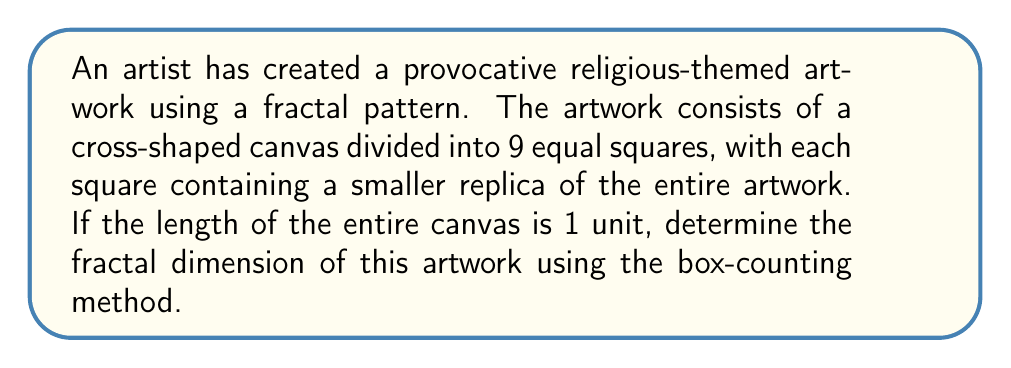Teach me how to tackle this problem. To determine the fractal dimension using the box-counting method, we follow these steps:

1. Identify the scaling factor (r):
   The artwork is divided into 9 equal squares, so the scaling factor is:
   $r = \frac{1}{3}$

2. Count the number of self-similar pieces (N):
   Each of the 9 squares contains a replica of the entire artwork, so:
   $N = 9$

3. Apply the fractal dimension formula:
   The fractal dimension D is given by:
   $$D = \frac{\log N}{\log(\frac{1}{r})}$$

4. Substitute the values:
   $$D = \frac{\log 9}{\log(\frac{1}{\frac{1}{3}})} = \frac{\log 9}{\log 3}$$

5. Calculate the result:
   $$D = \frac{\log 9}{\log 3} = \frac{2 \log 3}{\log 3} = 2$$

The fractal dimension of the artwork is 2, which indicates that it fills a 2-dimensional space completely, despite its intricate self-similar structure.
Answer: 2 